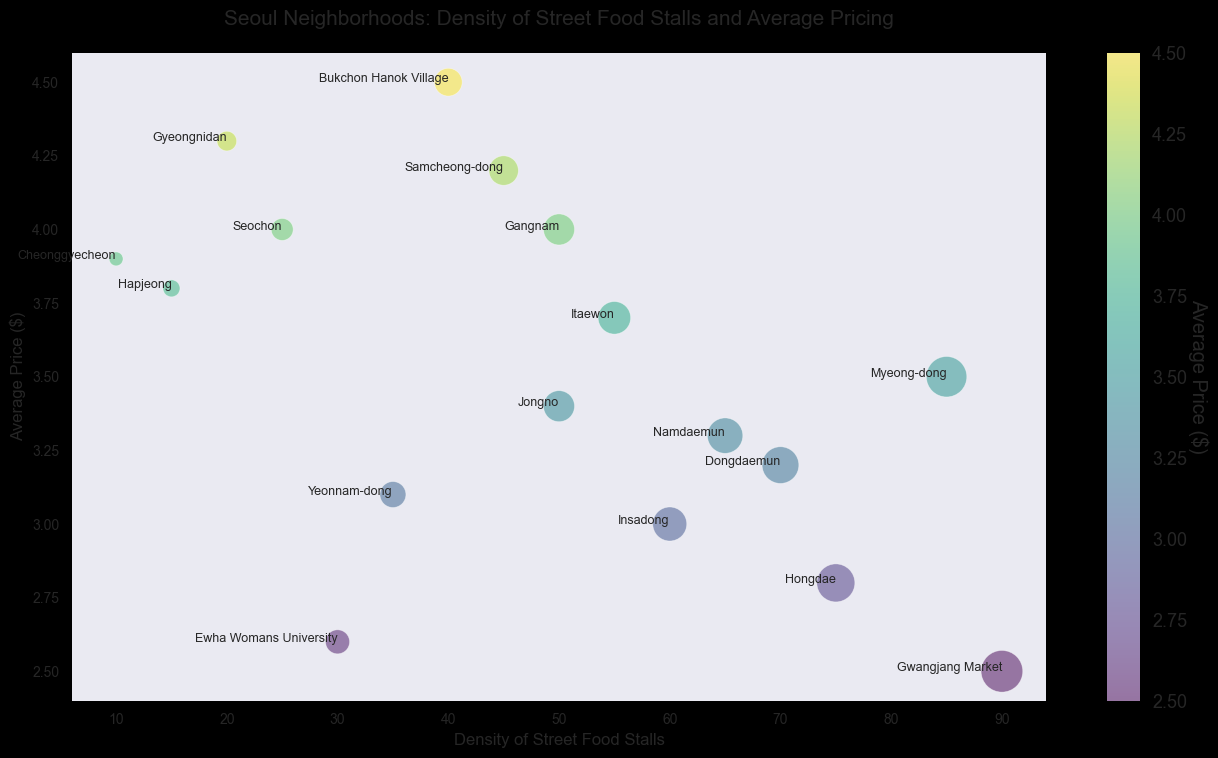What is the neighborhood with the highest density of street food stalls? Look at the placement of the bubbles based on their X-axis positions. The bubble farthest to the right indicates the highest density. "Gwangjang Market" is the farthest right meaning it has the highest density.
Answer: Gwangjang Market Which neighborhood has the highest average price for street food? Look at the placement of the bubbles based on their Y-axis positions. The bubble furthest up indicates the highest average price. "Bukchon Hanok Village" is the furthest up meaning it has the highest average price.
Answer: Bukchon Hanok Village What is the average price difference between Itaewon and Gyeongnidan? Find the average prices for Itaewon (3.70) and Gyeongnidan (4.30) and compute the difference: 4.30 - 3.70.
Answer: 0.60 Which neighborhood has the lowest density of street food stalls but high prices? Find the bubble closest to the leftmost part of the X-axis and towards the upper part of the Y-axis. "Cheonggyecheon" is both leftmost and high up.
Answer: Cheonggyecheon How many neighborhoods have an average price below $3.00? Identify bubbles positioned below the $3.00 mark on the Y-axis. Those would be Hongdae, Gwangjang Market, Ewha Womans University.
Answer: 3 Between Namdaemun and Dongdaemun, which has a higher density of street food stalls? Compare X-axis positions of the bubbles labeled "Namdaemun" and "Dongdaemun." "Dongdaemun" is further to the right.
Answer: Dongdaemun Which neighborhood combines both a high density of stalls and low average prices? Look for bubbles farthest right (high density) but also lower on the Y-axis (low average price). "Gwangjang Market" combines both criteria.
Answer: Gwangjang Market What is the average price of street food in Hongdae and Gangnam? Take the average prices for Hongdae (2.80) and Gangnam (4.00) and compute the average: (2.80 + 4.00) / 2.
Answer: 3.40 What neighborhood is closest to the average density of 50? Find bubbles around the 50 mark on the X-axis. Both "Gangnam" and "Jongno" are on the 50 mark.
Answer: Gangnam and Jongno 